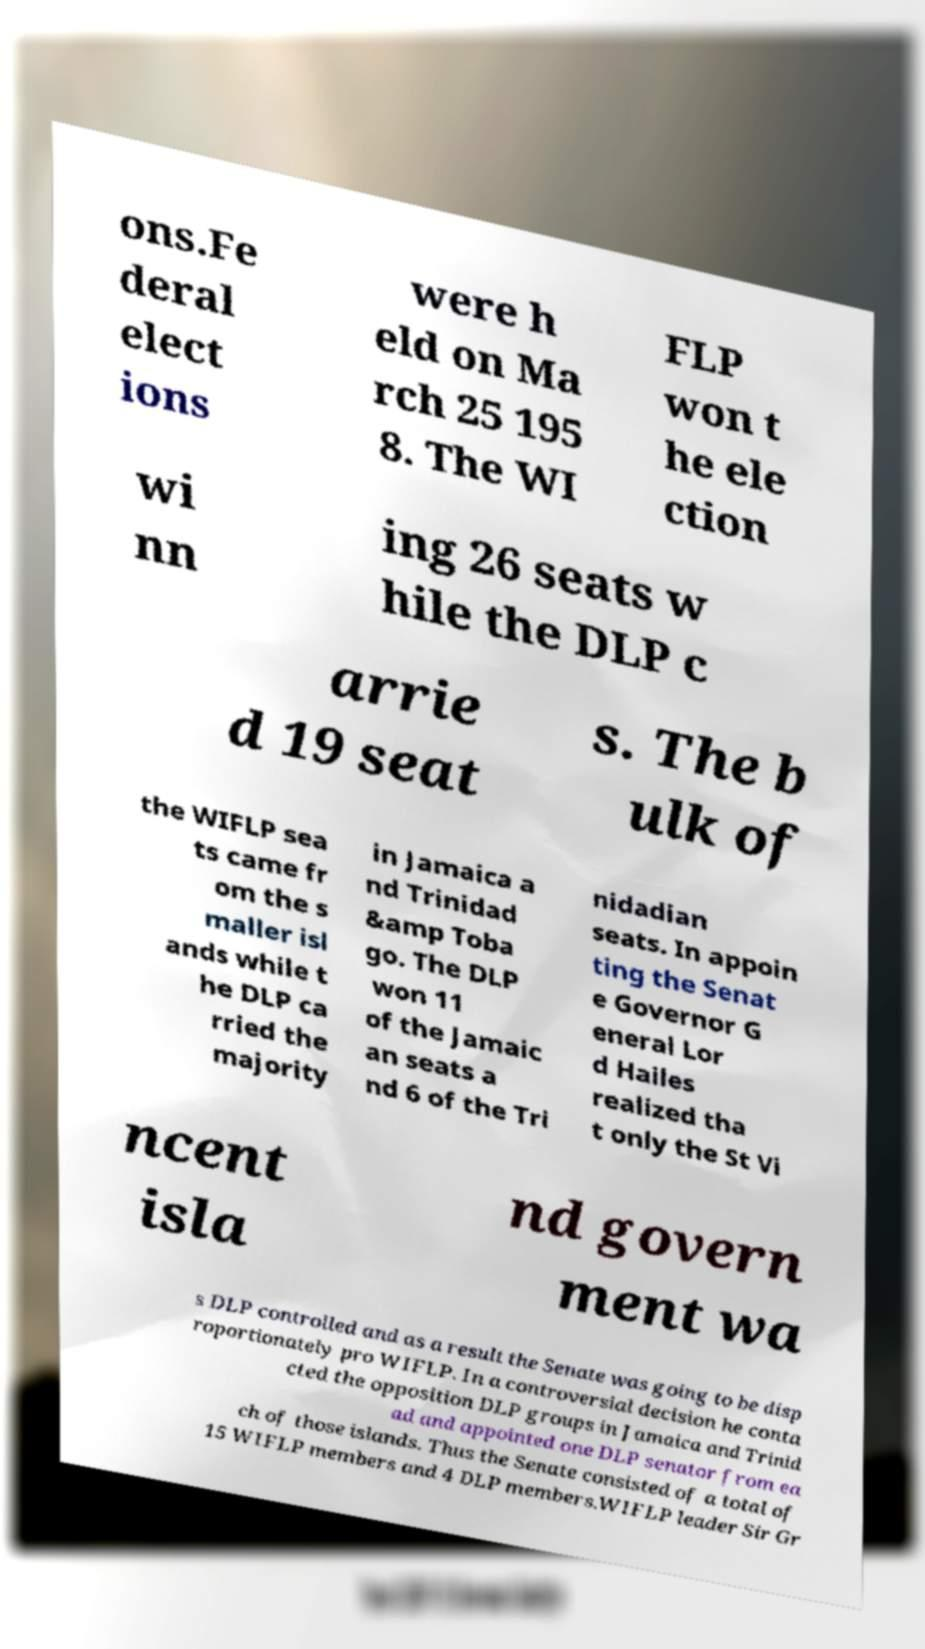Please identify and transcribe the text found in this image. ons.Fe deral elect ions were h eld on Ma rch 25 195 8. The WI FLP won t he ele ction wi nn ing 26 seats w hile the DLP c arrie d 19 seat s. The b ulk of the WIFLP sea ts came fr om the s maller isl ands while t he DLP ca rried the majority in Jamaica a nd Trinidad &amp Toba go. The DLP won 11 of the Jamaic an seats a nd 6 of the Tri nidadian seats. In appoin ting the Senat e Governor G eneral Lor d Hailes realized tha t only the St Vi ncent isla nd govern ment wa s DLP controlled and as a result the Senate was going to be disp roportionately pro WIFLP. In a controversial decision he conta cted the opposition DLP groups in Jamaica and Trinid ad and appointed one DLP senator from ea ch of those islands. Thus the Senate consisted of a total of 15 WIFLP members and 4 DLP members.WIFLP leader Sir Gr 